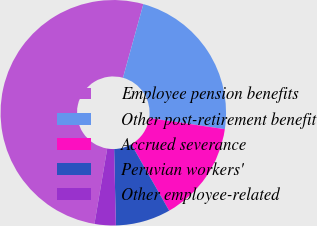Convert chart. <chart><loc_0><loc_0><loc_500><loc_500><pie_chart><fcel>Employee pension benefits<fcel>Other post-retirement benefit<fcel>Accrued severance<fcel>Peruvian workers'<fcel>Other employee-related<nl><fcel>51.62%<fcel>23.03%<fcel>14.42%<fcel>7.89%<fcel>3.04%<nl></chart> 